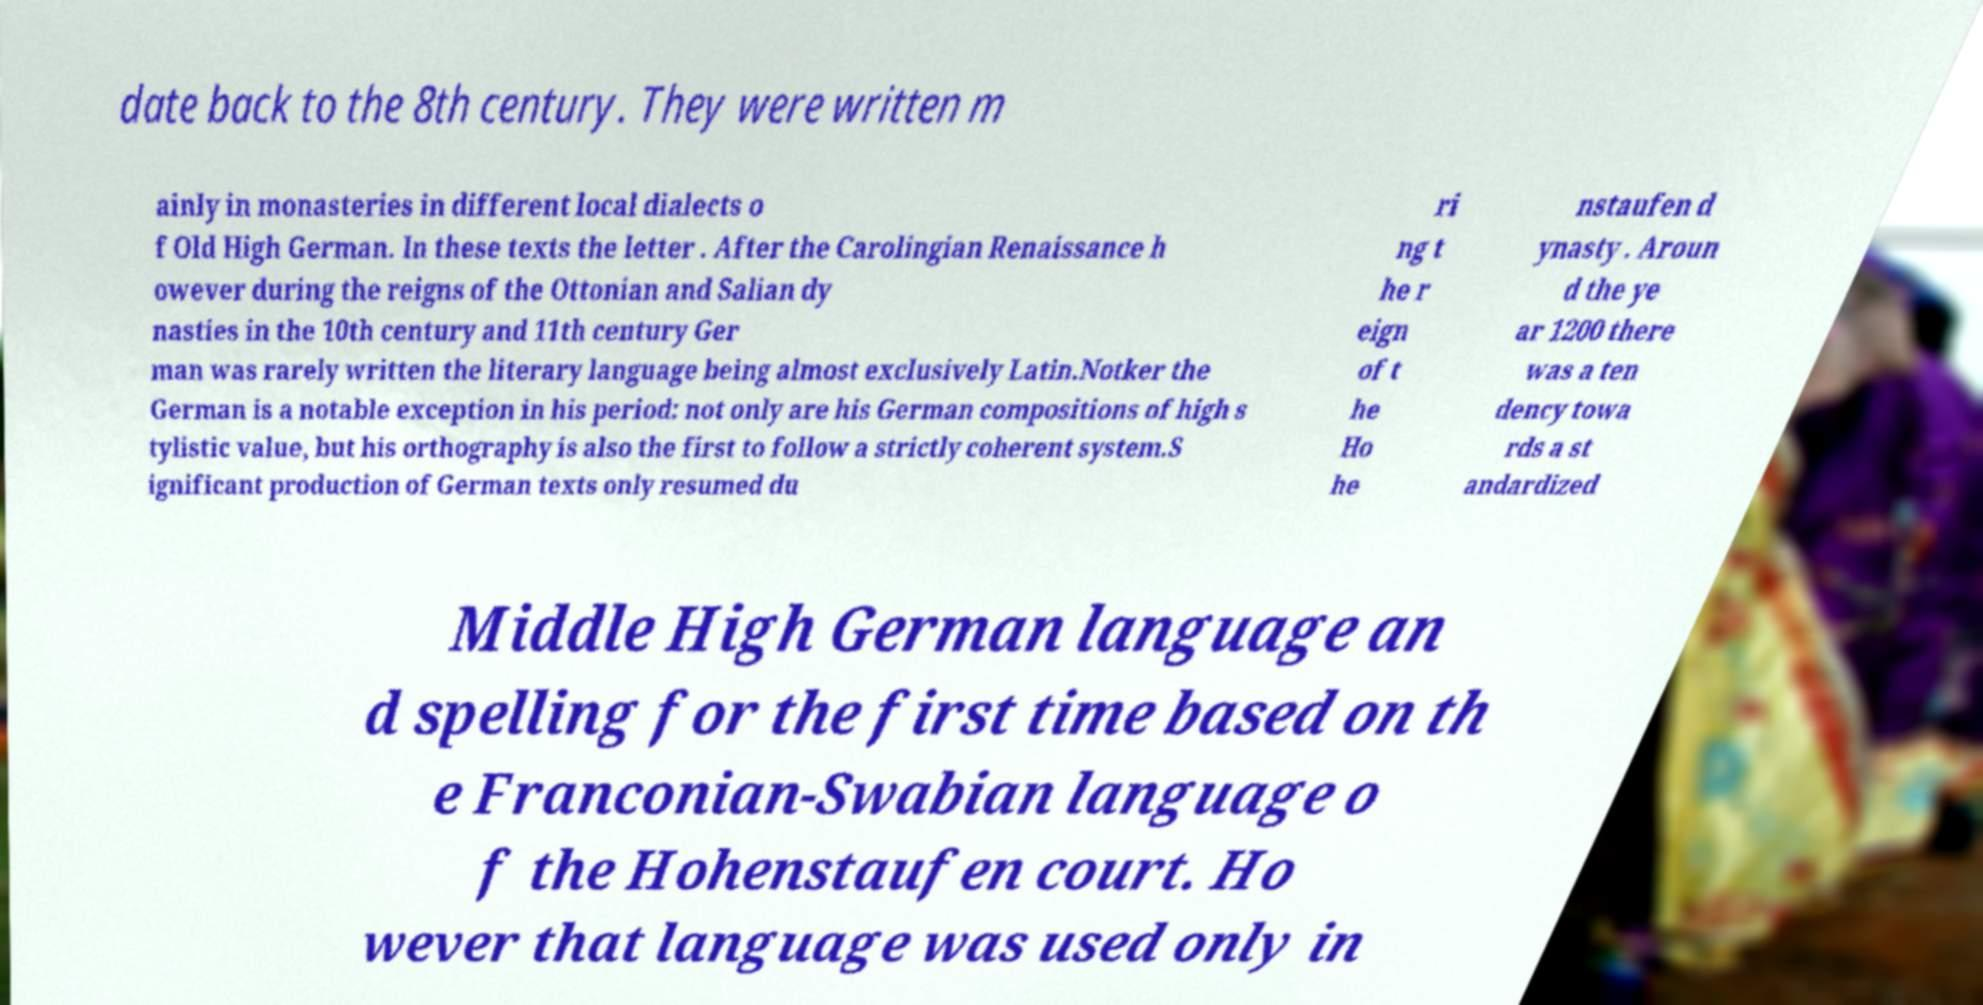I need the written content from this picture converted into text. Can you do that? date back to the 8th century. They were written m ainly in monasteries in different local dialects o f Old High German. In these texts the letter . After the Carolingian Renaissance h owever during the reigns of the Ottonian and Salian dy nasties in the 10th century and 11th century Ger man was rarely written the literary language being almost exclusively Latin.Notker the German is a notable exception in his period: not only are his German compositions of high s tylistic value, but his orthography is also the first to follow a strictly coherent system.S ignificant production of German texts only resumed du ri ng t he r eign of t he Ho he nstaufen d ynasty . Aroun d the ye ar 1200 there was a ten dency towa rds a st andardized Middle High German language an d spelling for the first time based on th e Franconian-Swabian language o f the Hohenstaufen court. Ho wever that language was used only in 